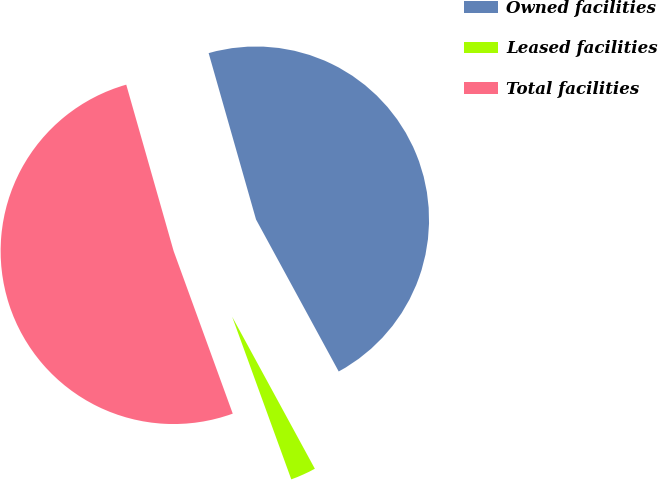Convert chart to OTSL. <chart><loc_0><loc_0><loc_500><loc_500><pie_chart><fcel>Owned facilities<fcel>Leased facilities<fcel>Total facilities<nl><fcel>46.49%<fcel>2.38%<fcel>51.14%<nl></chart> 